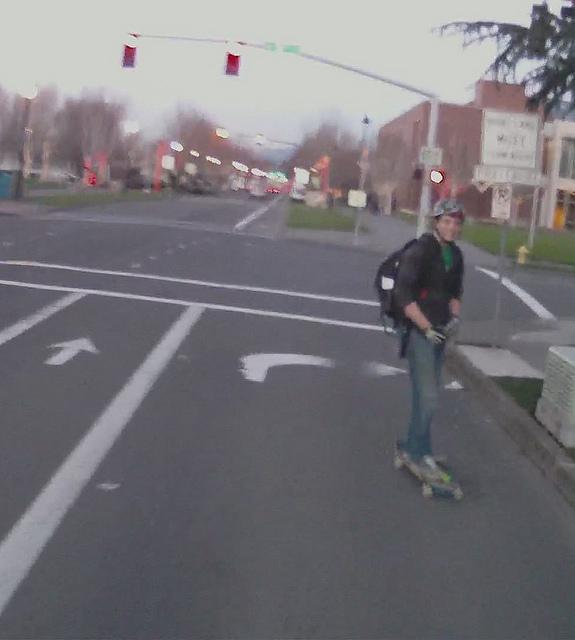A car turning which way is a hazard to this man?
Pick the correct solution from the four options below to address the question.
Options: Reversing, straight, left, right. Right. 